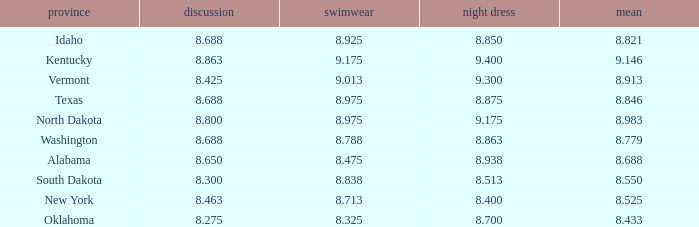Who had the lowest interview score from South Dakota with an evening gown less than 8.513? None. 